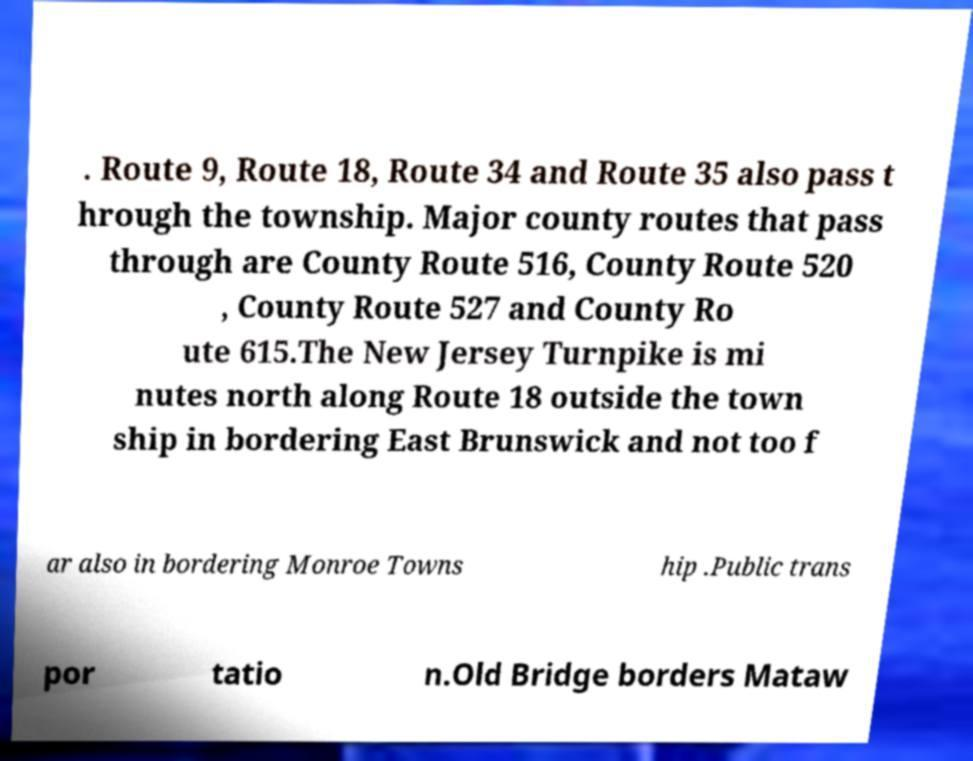There's text embedded in this image that I need extracted. Can you transcribe it verbatim? . Route 9, Route 18, Route 34 and Route 35 also pass t hrough the township. Major county routes that pass through are County Route 516, County Route 520 , County Route 527 and County Ro ute 615.The New Jersey Turnpike is mi nutes north along Route 18 outside the town ship in bordering East Brunswick and not too f ar also in bordering Monroe Towns hip .Public trans por tatio n.Old Bridge borders Mataw 